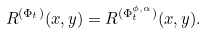<formula> <loc_0><loc_0><loc_500><loc_500>R ^ { ( \Phi _ { t } ) } ( x , y ) = R ^ { ( \Phi _ { t } ^ { \phi , \alpha } ) } ( x , y ) .</formula> 